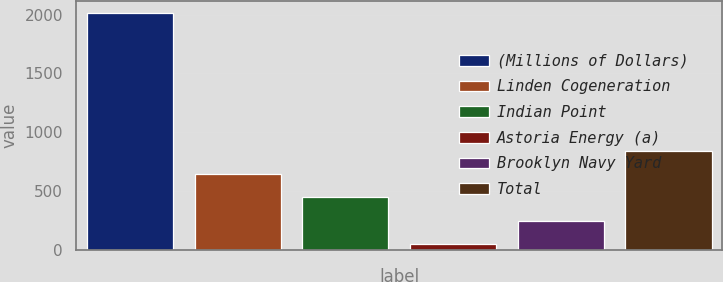Convert chart. <chart><loc_0><loc_0><loc_500><loc_500><bar_chart><fcel>(Millions of Dollars)<fcel>Linden Cogeneration<fcel>Indian Point<fcel>Astoria Energy (a)<fcel>Brooklyn Navy Yard<fcel>Total<nl><fcel>2016<fcel>639.8<fcel>443.2<fcel>50<fcel>246.6<fcel>836.4<nl></chart> 